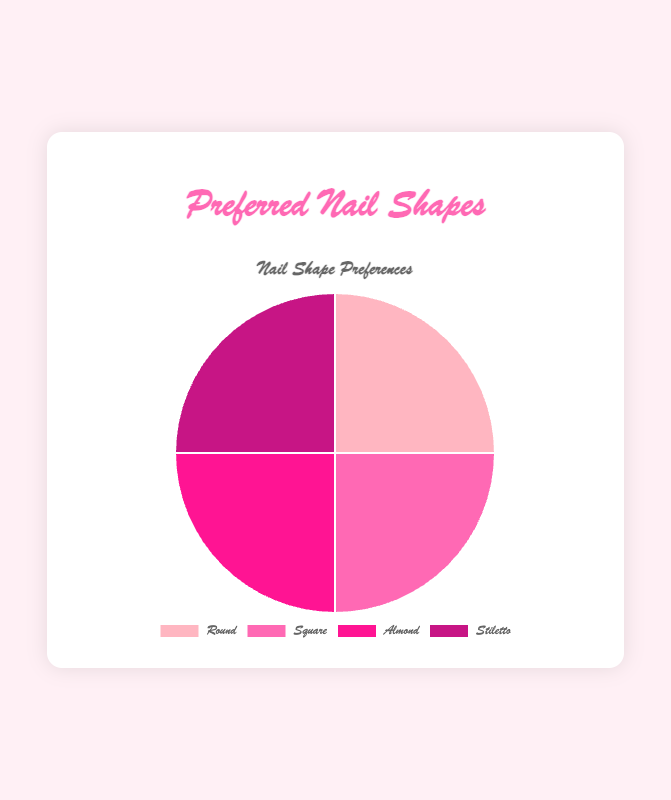What is the most popular nail shape? To determine the most popular nail shape, observe the segment of the pie chart with the largest area. This segment represents the nail shape category preferred by the most customers.
Answer: Round How many customers prefer the Stiletto shape? Identify the segment representing "Stiletto" in the pie chart and note the number of customers in that category. According to the data, 4 customers prefer "Stiletto."
Answer: 4 Which nail shape is preferred by the fewest number of customers? Look for the segment with the smallest area in the pie chart to find the least popular nail shape among the customers.
Answer: All shapes are equally preferred What is the combined percentage of customers who prefer Almond and Stiletto shapes? First, determine the number of customers for each shape: Almond (4) and Stiletto (4). Then, add these numbers (4 + 4 = 8). Finally, calculate the percentage by dividing by the total number of customers (16) and multiplying by 100.
Answer: 50% How do the preferences for Round and Square shapes compare visually? Examine the segments representing "Round" and "Square" shapes in the pie chart. Note their relative sizes to compare which one is preferred more often.
Answer: Round is more preferred than Square Which shape has an equal number of preferences as Almond? First, determine the number of customers who prefer Almond (4). Then, look for another segment with the same number of customers. The Stiletto shape also has 4 customers preferring it.
Answer: Stiletto Calculate the difference in the number of customers between the most and the least preferred shapes. Identify the maximum and minimum number of customers from the data (both values are the same at 4 since all shapes are equally preferred). The difference is 4 - 4 = 0.
Answer: 0 What is the percentage of customers preferring Round shape? Count the number of customers preferring the Round shape (5) and divide by the total number of customers (16). Multiply the result by 100 to get the percentage (5/16)*100.
Answer: 31.25% 